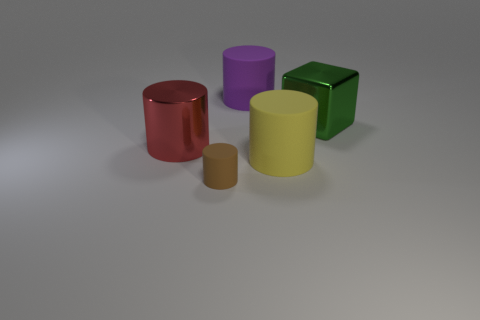Subtract all small brown matte cylinders. How many cylinders are left? 3 Add 3 small rubber cylinders. How many objects exist? 8 Subtract all purple cylinders. How many cylinders are left? 3 Add 5 big green matte balls. How many big green matte balls exist? 5 Subtract 0 gray spheres. How many objects are left? 5 Subtract all cylinders. How many objects are left? 1 Subtract all blue blocks. Subtract all brown cylinders. How many blocks are left? 1 Subtract all large yellow objects. Subtract all big metal blocks. How many objects are left? 3 Add 1 yellow matte cylinders. How many yellow matte cylinders are left? 2 